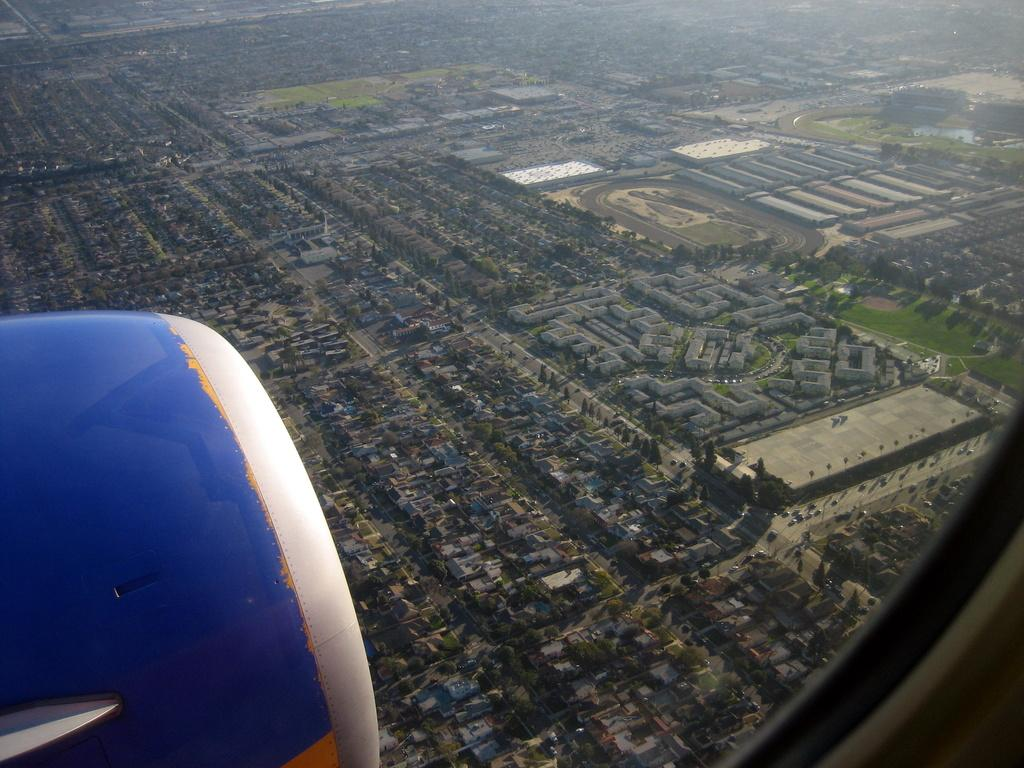What type of view is depicted in the image? The image is an aerial view. What structures can be seen in the image? There are buildings in the image. What else is visible in the image besides buildings? Vehicles, the ground, grass, and trees are visible in the image. Can you describe the bottom left corner of the image? A part of an airplane is present in the bottom left corner of the image. What type of wristwatch is visible on the tree in the image? There is no wristwatch present on the tree in the image. What type of frame surrounds the image? The image does not have a frame; it is a digital representation. 